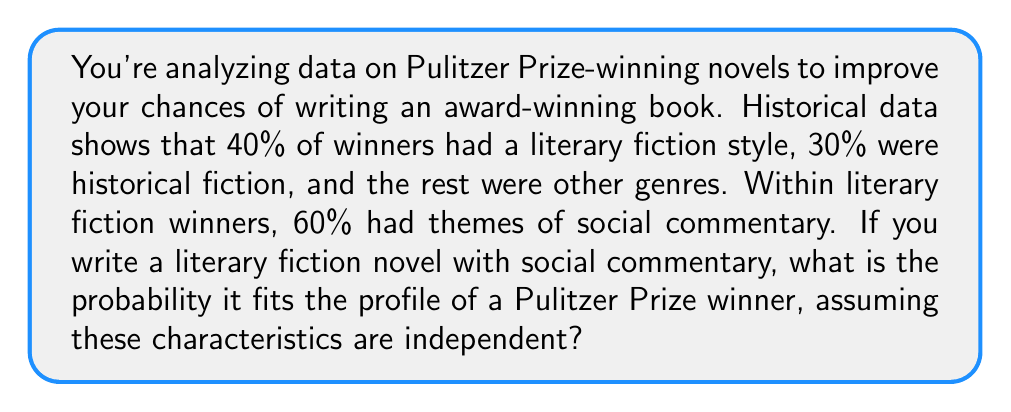Give your solution to this math problem. Let's approach this step-by-step:

1) First, we need to identify the two independent events:
   A: The book is literary fiction
   B: The book has social commentary themes

2) We're given the following probabilities:
   $P(A) = 0.40$ (40% of winners were literary fiction)
   $P(B|A) = 0.60$ (60% of literary fiction winners had social commentary)

3) To find the probability that a book fits both characteristics, we multiply these probabilities:

   $P(A \text{ and } B) = P(A) \times P(B|A)$

4) Substituting the values:

   $P(A \text{ and } B) = 0.40 \times 0.60 = 0.24$

5) Therefore, the probability that your book fits the profile of a Pulitzer Prize winner, given it's literary fiction with social commentary, is 0.24 or 24%.
Answer: 0.24 